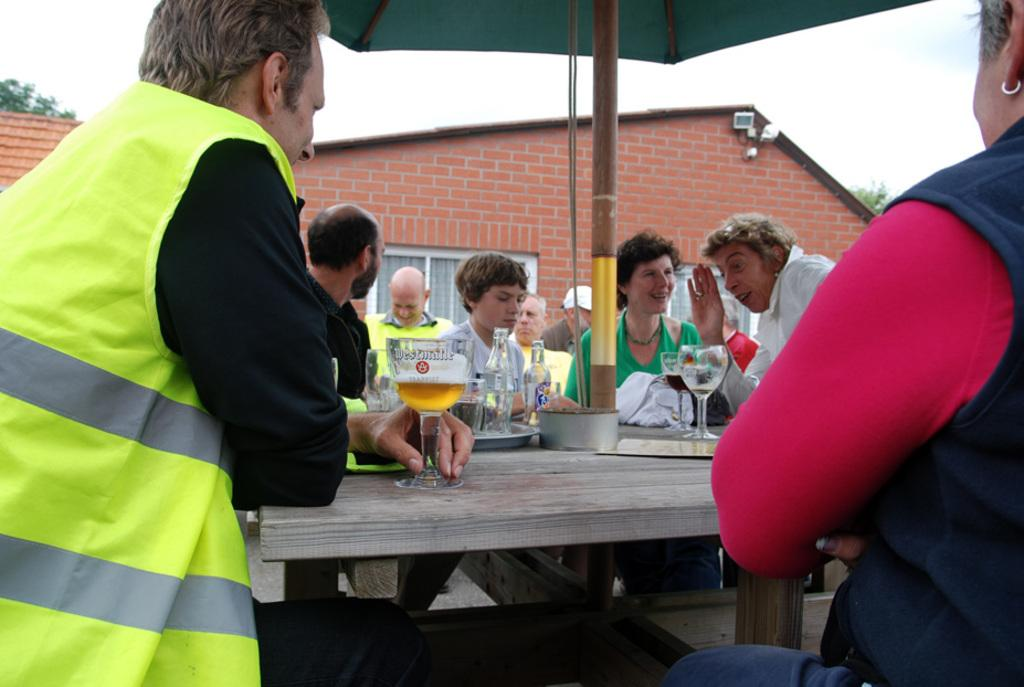What is happening in the image? There is a group of people in the image. Where are the people located in the image? The people are sitting around a table. What are the people holding in the image? The people are holding wine glasses. What type of bells can be heard ringing in the image? There are no bells present in the image, and therefore no sound can be heard. 